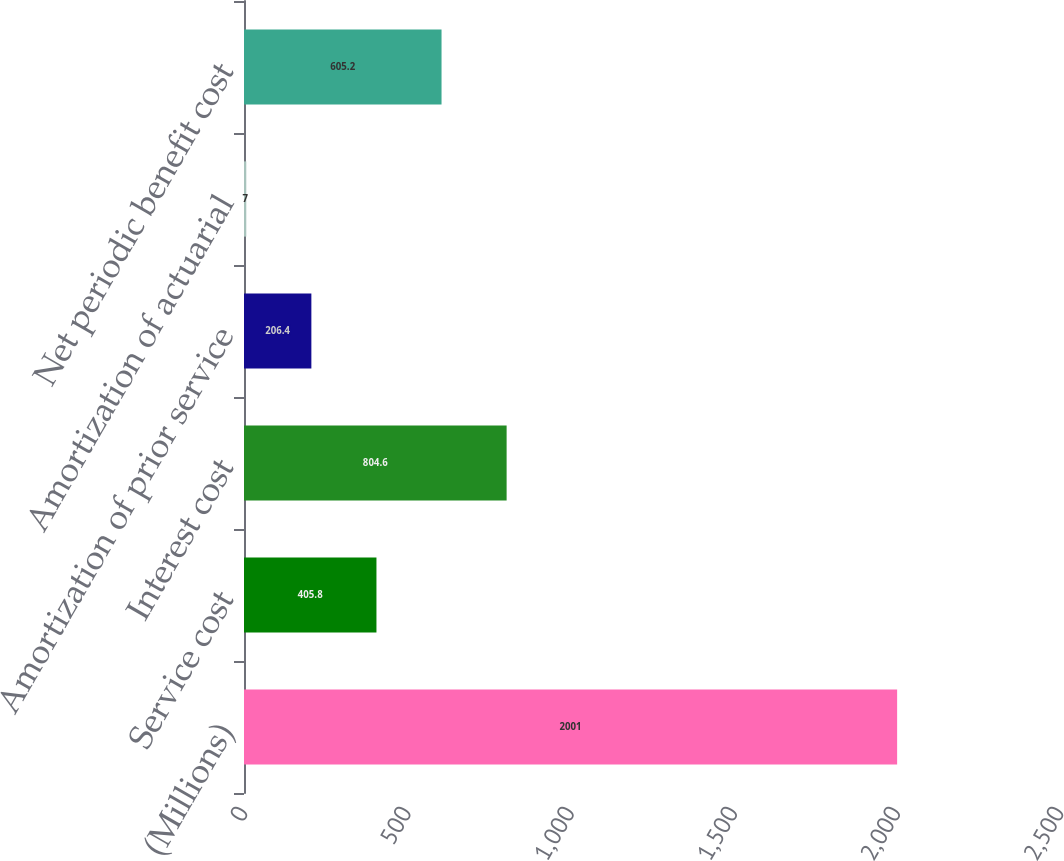Convert chart to OTSL. <chart><loc_0><loc_0><loc_500><loc_500><bar_chart><fcel>(Millions)<fcel>Service cost<fcel>Interest cost<fcel>Amortization of prior service<fcel>Amortization of actuarial<fcel>Net periodic benefit cost<nl><fcel>2001<fcel>405.8<fcel>804.6<fcel>206.4<fcel>7<fcel>605.2<nl></chart> 